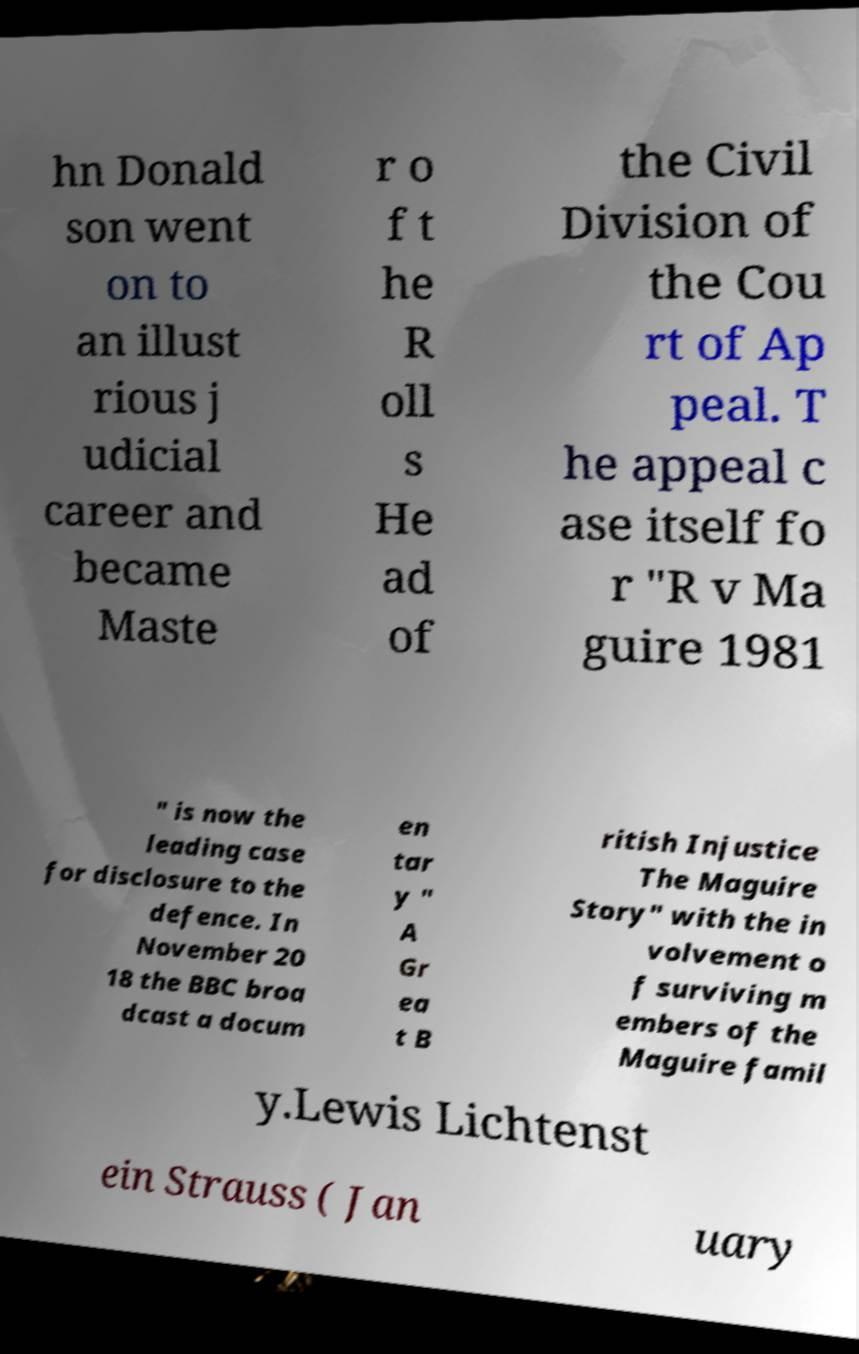Please identify and transcribe the text found in this image. hn Donald son went on to an illust rious j udicial career and became Maste r o f t he R oll s He ad of the Civil Division of the Cou rt of Ap peal. T he appeal c ase itself fo r "R v Ma guire 1981 " is now the leading case for disclosure to the defence. In November 20 18 the BBC broa dcast a docum en tar y " A Gr ea t B ritish Injustice The Maguire Story" with the in volvement o f surviving m embers of the Maguire famil y.Lewis Lichtenst ein Strauss ( Jan uary 